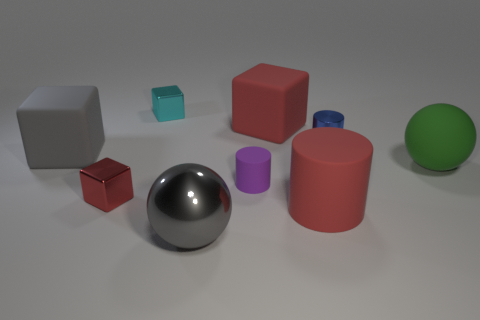How many big objects have the same color as the large matte cylinder?
Make the answer very short. 1. There is a red cube that is behind the purple rubber thing; does it have the same size as the big green matte sphere?
Your response must be concise. Yes. There is a tiny shiny thing that is both to the left of the red cylinder and behind the tiny red shiny cube; what color is it?
Offer a terse response. Cyan. How many objects are either large gray shiny blocks or large cubes to the right of the large gray metallic thing?
Make the answer very short. 1. There is a big red object left of the large red thing in front of the big matte cube that is right of the big gray cube; what is its material?
Make the answer very short. Rubber. Is there any other thing that is the same material as the green thing?
Offer a terse response. Yes. There is a large ball behind the small red thing; is it the same color as the large cylinder?
Make the answer very short. No. What number of purple things are either small matte cylinders or big rubber cylinders?
Provide a short and direct response. 1. How many other objects are the same shape as the purple object?
Provide a succinct answer. 2. Is the purple object made of the same material as the large cylinder?
Your answer should be compact. Yes. 